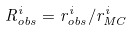<formula> <loc_0><loc_0><loc_500><loc_500>R _ { o b s } ^ { i } = r _ { o b s } ^ { i } / r _ { M C } ^ { i }</formula> 